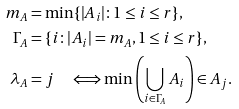<formula> <loc_0><loc_0><loc_500><loc_500>m _ { A } & = \min \{ | A _ { i } | \colon 1 \leq i \leq r \} , \\ \Gamma _ { A } & = \{ i \colon | A _ { i } | = m _ { A } , 1 \leq i \leq r \} , \\ \lambda _ { A } & = j \quad \Longleftrightarrow \min \left ( \bigcup _ { i \in \Gamma _ { A } } A _ { i } \right ) \in A _ { j } .</formula> 